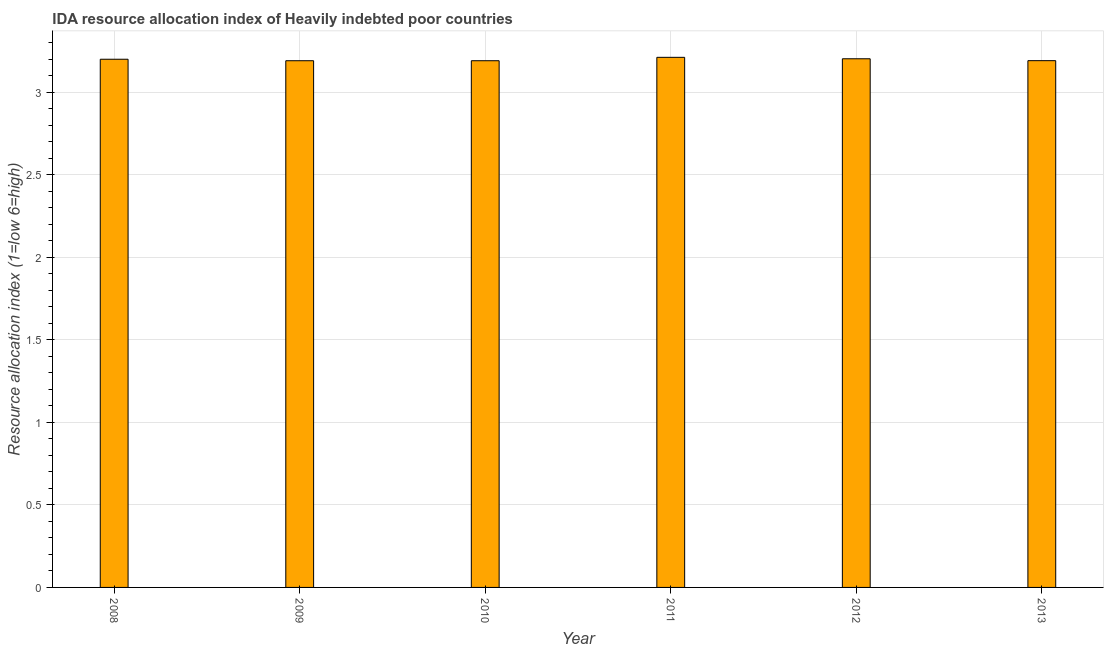Does the graph contain grids?
Provide a succinct answer. Yes. What is the title of the graph?
Your answer should be very brief. IDA resource allocation index of Heavily indebted poor countries. What is the label or title of the X-axis?
Offer a terse response. Year. What is the label or title of the Y-axis?
Offer a terse response. Resource allocation index (1=low 6=high). What is the ida resource allocation index in 2011?
Offer a very short reply. 3.21. Across all years, what is the maximum ida resource allocation index?
Your answer should be compact. 3.21. Across all years, what is the minimum ida resource allocation index?
Your answer should be compact. 3.19. In which year was the ida resource allocation index maximum?
Ensure brevity in your answer.  2011. What is the sum of the ida resource allocation index?
Your answer should be compact. 19.19. What is the difference between the ida resource allocation index in 2011 and 2012?
Make the answer very short. 0.01. What is the average ida resource allocation index per year?
Your answer should be very brief. 3.2. What is the median ida resource allocation index?
Ensure brevity in your answer.  3.2. In how many years, is the ida resource allocation index greater than 2.2 ?
Your answer should be compact. 6. Do a majority of the years between 2011 and 2013 (inclusive) have ida resource allocation index greater than 0.3 ?
Offer a very short reply. Yes. Is the ida resource allocation index in 2008 less than that in 2011?
Keep it short and to the point. Yes. What is the difference between the highest and the second highest ida resource allocation index?
Provide a succinct answer. 0.01. Is the sum of the ida resource allocation index in 2008 and 2010 greater than the maximum ida resource allocation index across all years?
Your answer should be very brief. Yes. In how many years, is the ida resource allocation index greater than the average ida resource allocation index taken over all years?
Give a very brief answer. 3. What is the difference between two consecutive major ticks on the Y-axis?
Keep it short and to the point. 0.5. Are the values on the major ticks of Y-axis written in scientific E-notation?
Offer a terse response. No. What is the Resource allocation index (1=low 6=high) in 2009?
Offer a very short reply. 3.19. What is the Resource allocation index (1=low 6=high) of 2010?
Your response must be concise. 3.19. What is the Resource allocation index (1=low 6=high) in 2011?
Make the answer very short. 3.21. What is the Resource allocation index (1=low 6=high) of 2012?
Provide a succinct answer. 3.2. What is the Resource allocation index (1=low 6=high) in 2013?
Offer a very short reply. 3.19. What is the difference between the Resource allocation index (1=low 6=high) in 2008 and 2009?
Your response must be concise. 0.01. What is the difference between the Resource allocation index (1=low 6=high) in 2008 and 2010?
Make the answer very short. 0.01. What is the difference between the Resource allocation index (1=low 6=high) in 2008 and 2011?
Make the answer very short. -0.01. What is the difference between the Resource allocation index (1=low 6=high) in 2008 and 2012?
Provide a succinct answer. -0. What is the difference between the Resource allocation index (1=low 6=high) in 2008 and 2013?
Keep it short and to the point. 0.01. What is the difference between the Resource allocation index (1=low 6=high) in 2009 and 2011?
Your answer should be very brief. -0.02. What is the difference between the Resource allocation index (1=low 6=high) in 2009 and 2012?
Keep it short and to the point. -0.01. What is the difference between the Resource allocation index (1=low 6=high) in 2009 and 2013?
Your answer should be very brief. -0. What is the difference between the Resource allocation index (1=low 6=high) in 2010 and 2011?
Make the answer very short. -0.02. What is the difference between the Resource allocation index (1=low 6=high) in 2010 and 2012?
Offer a terse response. -0.01. What is the difference between the Resource allocation index (1=low 6=high) in 2010 and 2013?
Your response must be concise. -0. What is the difference between the Resource allocation index (1=low 6=high) in 2011 and 2012?
Your answer should be compact. 0.01. What is the difference between the Resource allocation index (1=low 6=high) in 2011 and 2013?
Your answer should be compact. 0.02. What is the difference between the Resource allocation index (1=low 6=high) in 2012 and 2013?
Your response must be concise. 0.01. What is the ratio of the Resource allocation index (1=low 6=high) in 2008 to that in 2009?
Make the answer very short. 1. What is the ratio of the Resource allocation index (1=low 6=high) in 2008 to that in 2010?
Give a very brief answer. 1. What is the ratio of the Resource allocation index (1=low 6=high) in 2008 to that in 2012?
Your response must be concise. 1. What is the ratio of the Resource allocation index (1=low 6=high) in 2008 to that in 2013?
Keep it short and to the point. 1. What is the ratio of the Resource allocation index (1=low 6=high) in 2009 to that in 2010?
Give a very brief answer. 1. What is the ratio of the Resource allocation index (1=low 6=high) in 2009 to that in 2011?
Give a very brief answer. 0.99. What is the ratio of the Resource allocation index (1=low 6=high) in 2009 to that in 2012?
Ensure brevity in your answer.  1. What is the ratio of the Resource allocation index (1=low 6=high) in 2009 to that in 2013?
Provide a succinct answer. 1. What is the ratio of the Resource allocation index (1=low 6=high) in 2010 to that in 2011?
Ensure brevity in your answer.  0.99. What is the ratio of the Resource allocation index (1=low 6=high) in 2010 to that in 2013?
Provide a succinct answer. 1. What is the ratio of the Resource allocation index (1=low 6=high) in 2011 to that in 2012?
Your answer should be compact. 1. What is the ratio of the Resource allocation index (1=low 6=high) in 2012 to that in 2013?
Offer a very short reply. 1. 